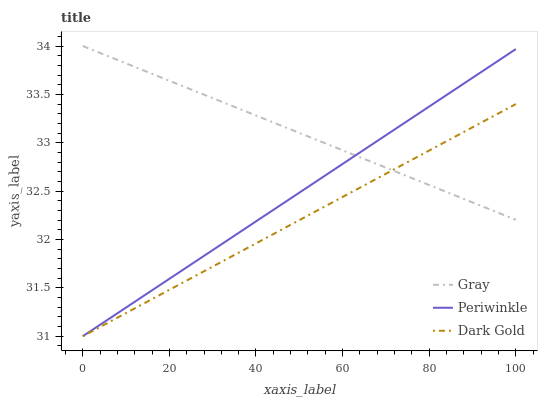Does Dark Gold have the minimum area under the curve?
Answer yes or no. Yes. Does Gray have the maximum area under the curve?
Answer yes or no. Yes. Does Periwinkle have the minimum area under the curve?
Answer yes or no. No. Does Periwinkle have the maximum area under the curve?
Answer yes or no. No. Is Dark Gold the smoothest?
Answer yes or no. Yes. Is Gray the roughest?
Answer yes or no. Yes. Is Periwinkle the smoothest?
Answer yes or no. No. Is Periwinkle the roughest?
Answer yes or no. No. Does Periwinkle have the highest value?
Answer yes or no. No. 